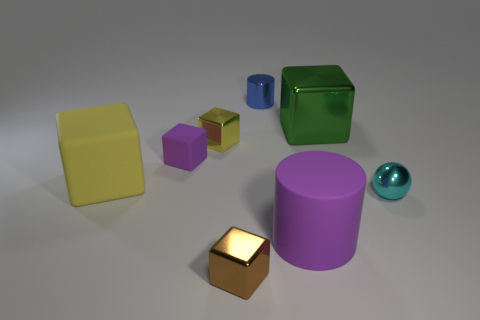Subtract all purple cubes. How many cubes are left? 4 Add 1 yellow metal objects. How many objects exist? 9 Subtract all spheres. How many objects are left? 7 Subtract all green blocks. How many blocks are left? 4 Subtract 1 blocks. How many blocks are left? 4 Subtract all green things. Subtract all small balls. How many objects are left? 6 Add 7 small rubber objects. How many small rubber objects are left? 8 Add 1 yellow objects. How many yellow objects exist? 3 Subtract 0 blue blocks. How many objects are left? 8 Subtract all blue blocks. Subtract all purple cylinders. How many blocks are left? 5 